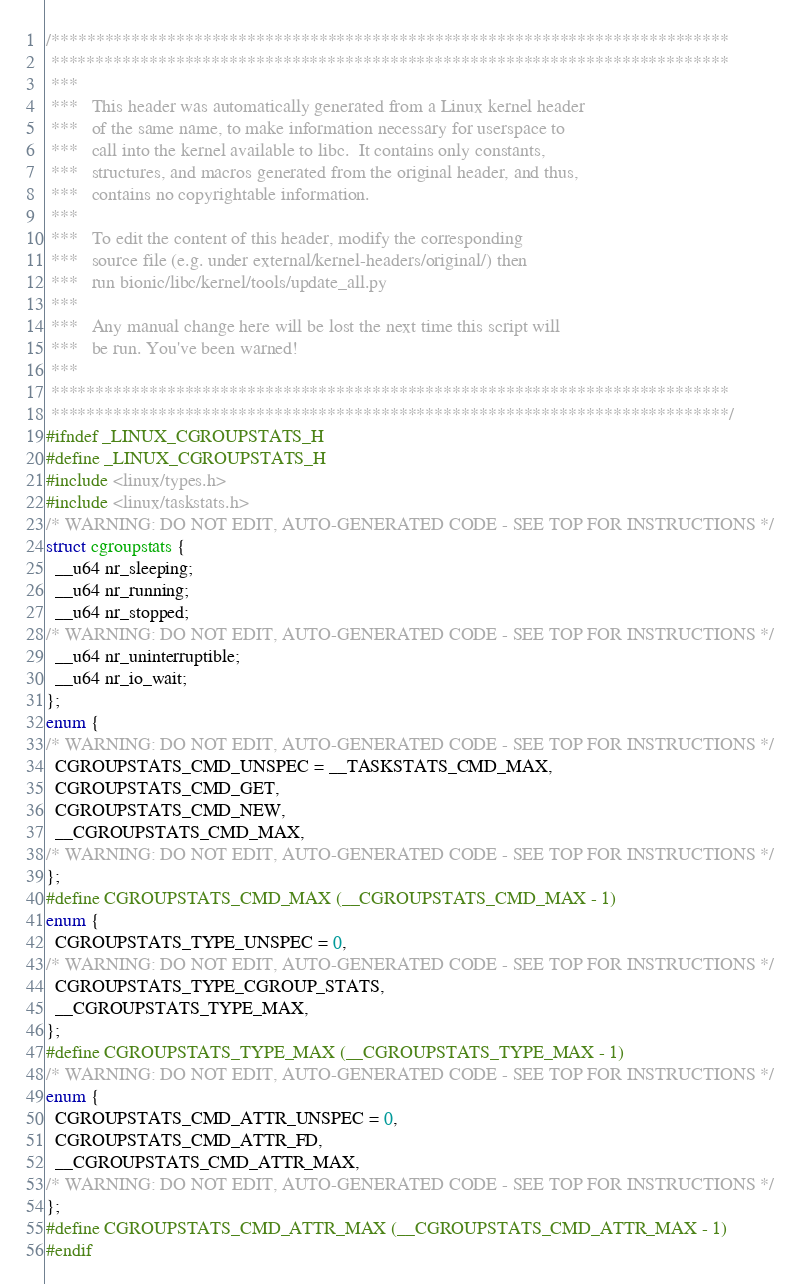Convert code to text. <code><loc_0><loc_0><loc_500><loc_500><_C_>/****************************************************************************
 ****************************************************************************
 ***
 ***   This header was automatically generated from a Linux kernel header
 ***   of the same name, to make information necessary for userspace to
 ***   call into the kernel available to libc.  It contains only constants,
 ***   structures, and macros generated from the original header, and thus,
 ***   contains no copyrightable information.
 ***
 ***   To edit the content of this header, modify the corresponding
 ***   source file (e.g. under external/kernel-headers/original/) then
 ***   run bionic/libc/kernel/tools/update_all.py
 ***
 ***   Any manual change here will be lost the next time this script will
 ***   be run. You've been warned!
 ***
 ****************************************************************************
 ****************************************************************************/
#ifndef _LINUX_CGROUPSTATS_H
#define _LINUX_CGROUPSTATS_H
#include <linux/types.h>
#include <linux/taskstats.h>
/* WARNING: DO NOT EDIT, AUTO-GENERATED CODE - SEE TOP FOR INSTRUCTIONS */
struct cgroupstats {
  __u64 nr_sleeping;
  __u64 nr_running;
  __u64 nr_stopped;
/* WARNING: DO NOT EDIT, AUTO-GENERATED CODE - SEE TOP FOR INSTRUCTIONS */
  __u64 nr_uninterruptible;
  __u64 nr_io_wait;
};
enum {
/* WARNING: DO NOT EDIT, AUTO-GENERATED CODE - SEE TOP FOR INSTRUCTIONS */
  CGROUPSTATS_CMD_UNSPEC = __TASKSTATS_CMD_MAX,
  CGROUPSTATS_CMD_GET,
  CGROUPSTATS_CMD_NEW,
  __CGROUPSTATS_CMD_MAX,
/* WARNING: DO NOT EDIT, AUTO-GENERATED CODE - SEE TOP FOR INSTRUCTIONS */
};
#define CGROUPSTATS_CMD_MAX (__CGROUPSTATS_CMD_MAX - 1)
enum {
  CGROUPSTATS_TYPE_UNSPEC = 0,
/* WARNING: DO NOT EDIT, AUTO-GENERATED CODE - SEE TOP FOR INSTRUCTIONS */
  CGROUPSTATS_TYPE_CGROUP_STATS,
  __CGROUPSTATS_TYPE_MAX,
};
#define CGROUPSTATS_TYPE_MAX (__CGROUPSTATS_TYPE_MAX - 1)
/* WARNING: DO NOT EDIT, AUTO-GENERATED CODE - SEE TOP FOR INSTRUCTIONS */
enum {
  CGROUPSTATS_CMD_ATTR_UNSPEC = 0,
  CGROUPSTATS_CMD_ATTR_FD,
  __CGROUPSTATS_CMD_ATTR_MAX,
/* WARNING: DO NOT EDIT, AUTO-GENERATED CODE - SEE TOP FOR INSTRUCTIONS */
};
#define CGROUPSTATS_CMD_ATTR_MAX (__CGROUPSTATS_CMD_ATTR_MAX - 1)
#endif
</code> 